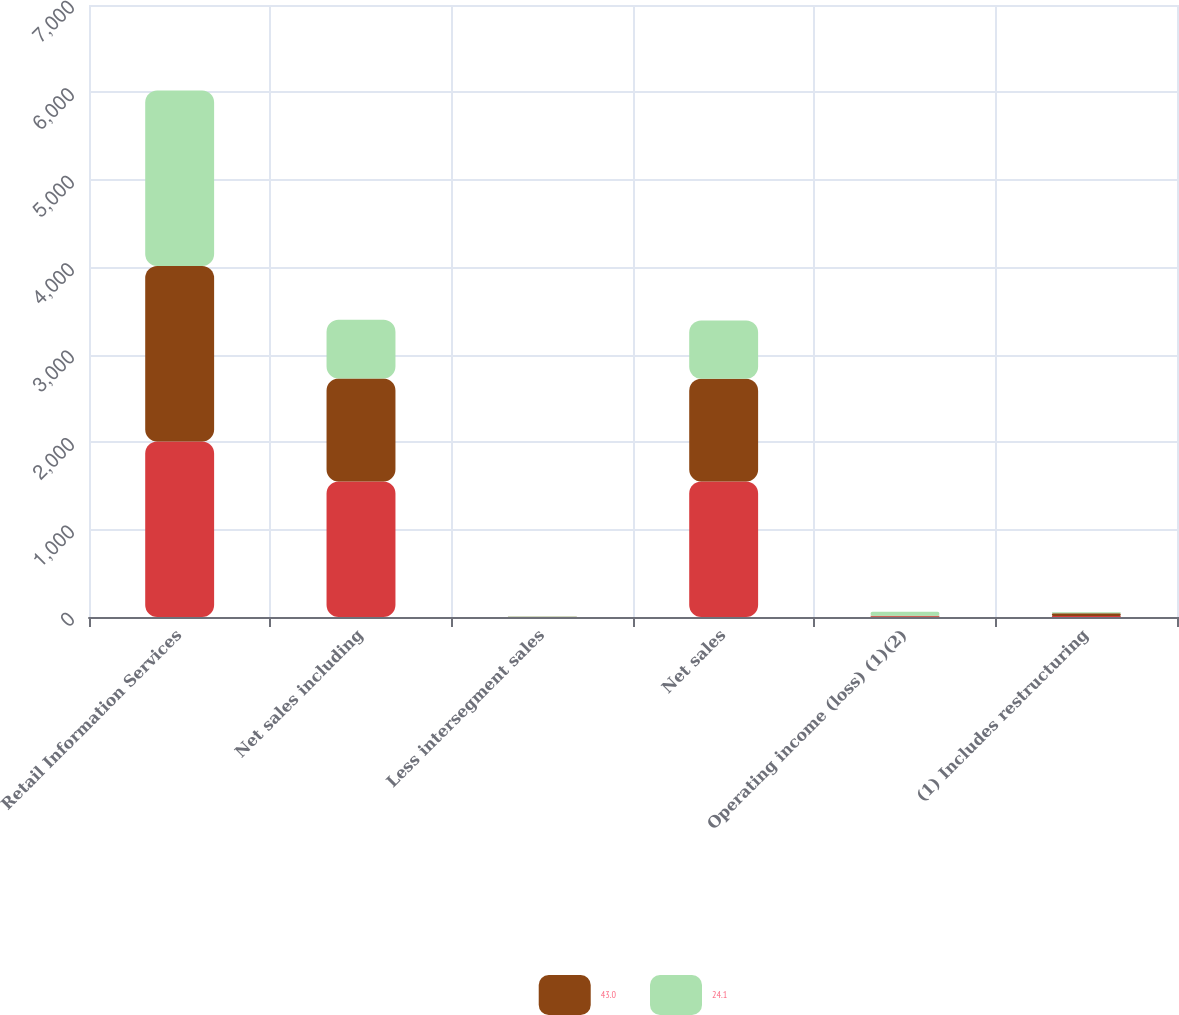<chart> <loc_0><loc_0><loc_500><loc_500><stacked_bar_chart><ecel><fcel>Retail Information Services<fcel>Net sales including<fcel>Less intersegment sales<fcel>Net sales<fcel>Operating income (loss) (1)(2)<fcel>(1) Includes restructuring<nl><fcel>nan<fcel>2008<fcel>1550.8<fcel>2.1<fcel>1548.7<fcel>9.4<fcel>11.4<nl><fcel>43<fcel>2007<fcel>1177.5<fcel>2.1<fcel>1175.4<fcel>5.7<fcel>31.2<nl><fcel>24.1<fcel>2006<fcel>671.4<fcel>3.4<fcel>668<fcel>45.2<fcel>11.2<nl></chart> 